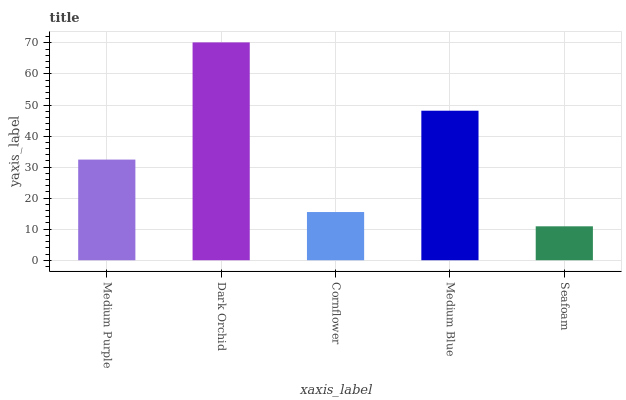Is Seafoam the minimum?
Answer yes or no. Yes. Is Dark Orchid the maximum?
Answer yes or no. Yes. Is Cornflower the minimum?
Answer yes or no. No. Is Cornflower the maximum?
Answer yes or no. No. Is Dark Orchid greater than Cornflower?
Answer yes or no. Yes. Is Cornflower less than Dark Orchid?
Answer yes or no. Yes. Is Cornflower greater than Dark Orchid?
Answer yes or no. No. Is Dark Orchid less than Cornflower?
Answer yes or no. No. Is Medium Purple the high median?
Answer yes or no. Yes. Is Medium Purple the low median?
Answer yes or no. Yes. Is Cornflower the high median?
Answer yes or no. No. Is Cornflower the low median?
Answer yes or no. No. 